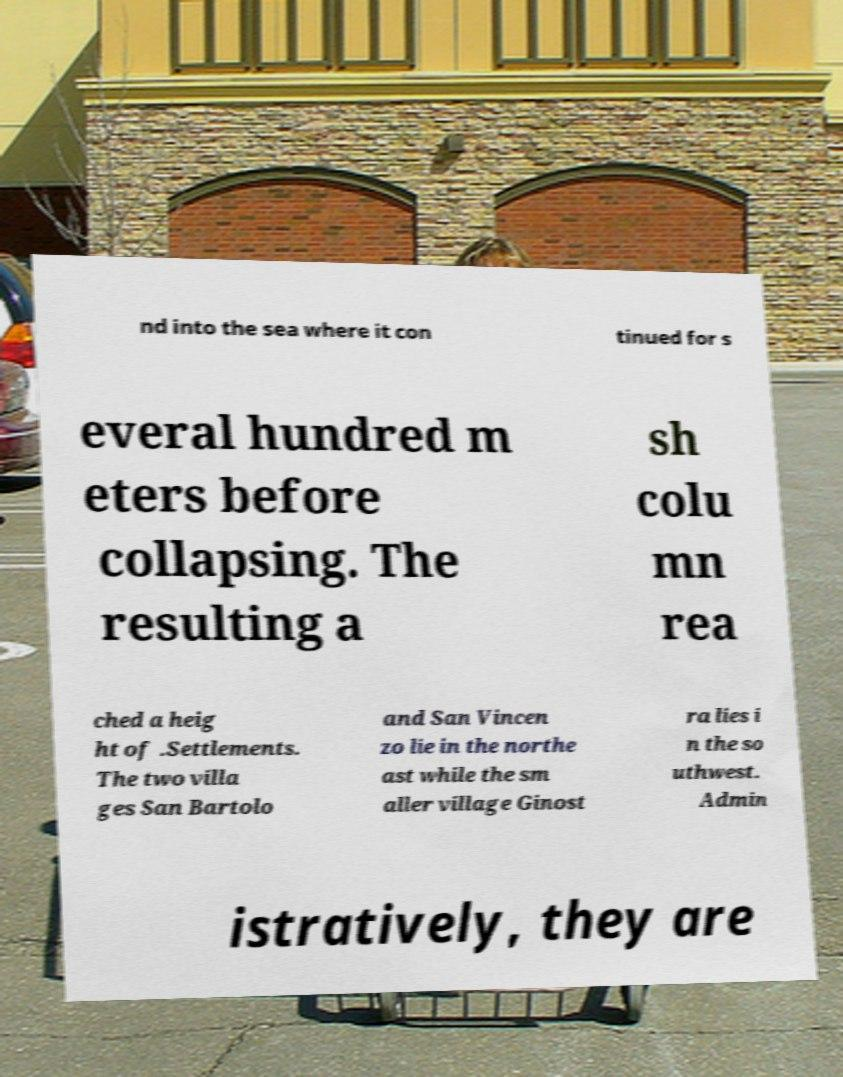There's text embedded in this image that I need extracted. Can you transcribe it verbatim? nd into the sea where it con tinued for s everal hundred m eters before collapsing. The resulting a sh colu mn rea ched a heig ht of .Settlements. The two villa ges San Bartolo and San Vincen zo lie in the northe ast while the sm aller village Ginost ra lies i n the so uthwest. Admin istratively, they are 